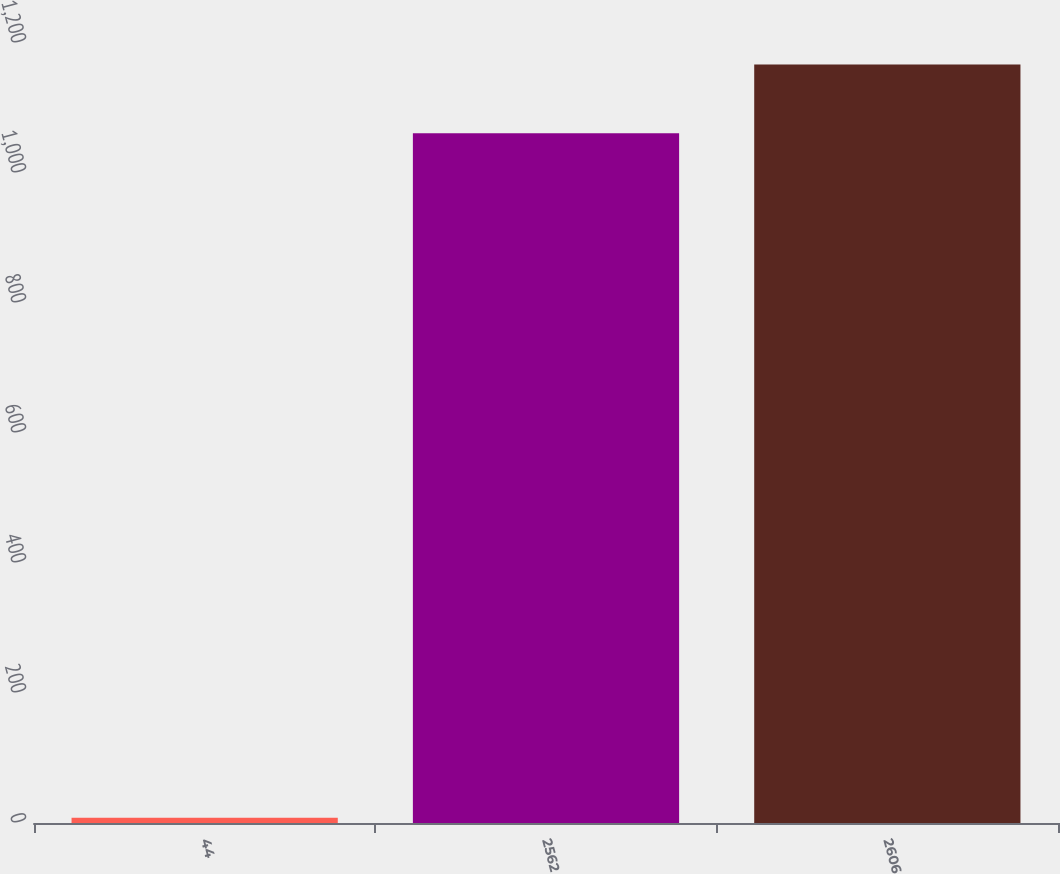<chart> <loc_0><loc_0><loc_500><loc_500><bar_chart><fcel>44<fcel>2562<fcel>2606<nl><fcel>8<fcel>1061<fcel>1167.1<nl></chart> 